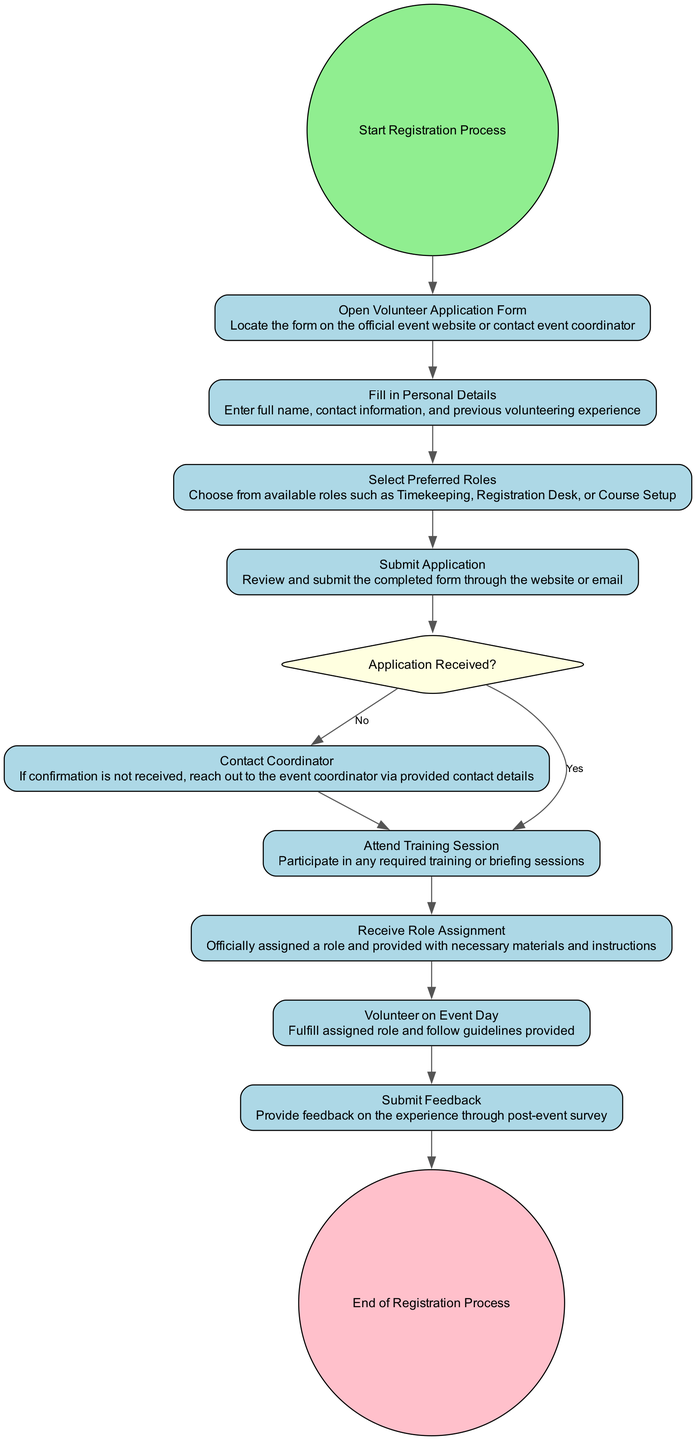What is the starting point of the registration process? The diagram begins with the "Start Registration Process" node, indicating where the registration initiative kicks off.
Answer: Start Registration Process What do you fill in after opening the volunteer application form? Following the "Open Volunteer Application Form" step, the next activity is "Fill in Personal Details" where specific personal information is required.
Answer: Fill in Personal Details How many preferred roles can a volunteer select? The diagram indicates a step labeled "Select Preferred Roles," which suggests that there are multiple roles to choose from without specifying an exact number, it clearly allows for selecting among various options.
Answer: Multiple roles What action follows receiving confirmation of the application? Once the confirmation email is received (yes scenario), the next step is to "Attend Training Session," indicating preparation for volunteering.
Answer: Attend Training Session What should a volunteer do if they do not receive a confirmation email within 24 hours? The diagram outlines that the action in case of no confirmation is to "Contact Coordinator," which is the immediate next step for clarification.
Answer: Contact Coordinator What happens before a volunteer can receive their role assignment? Before receiving the role assignment, a volunteer must participate in the "Attend Training Session," ensuring readiness for the assigned roles.
Answer: Attend Training Session How does the process end after volunteering on event day? The final step after fulfilling the role on event day is to "Submit Feedback," which wraps up the volunteer experience and concludes the registration process.
Answer: Submit Feedback What signifies the completion of the registration process? The end of the process is marked by the node "End of Registration Process," indicating that all steps have been followed and the formal registration is complete.
Answer: End of Registration Process What is the role of the decision node in this flow chart? The decision node titled "Application Received?" directs the flow based on whether a confirmation email was received, leading to different subsequent actions depending on the outcome.
Answer: Application Received? 